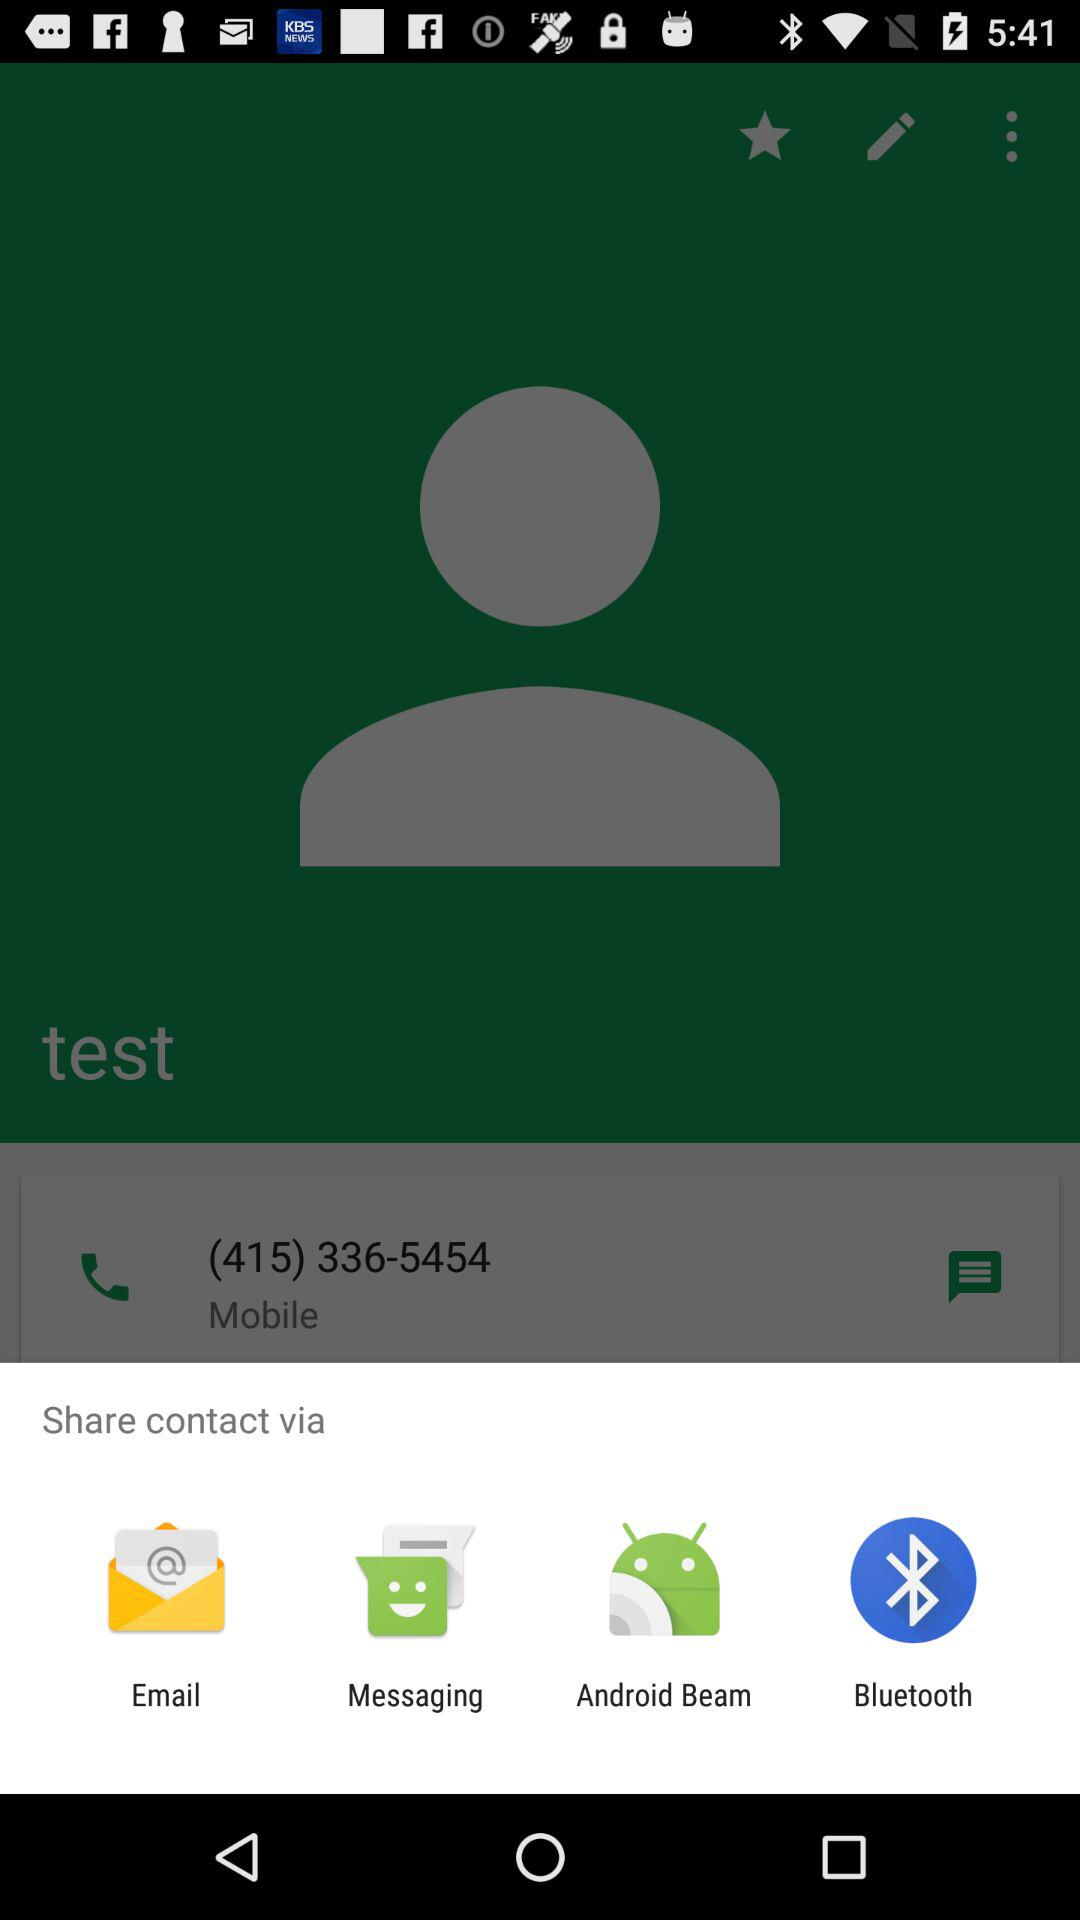What is the contact number of test? The contact number is (415) 336-5454. 